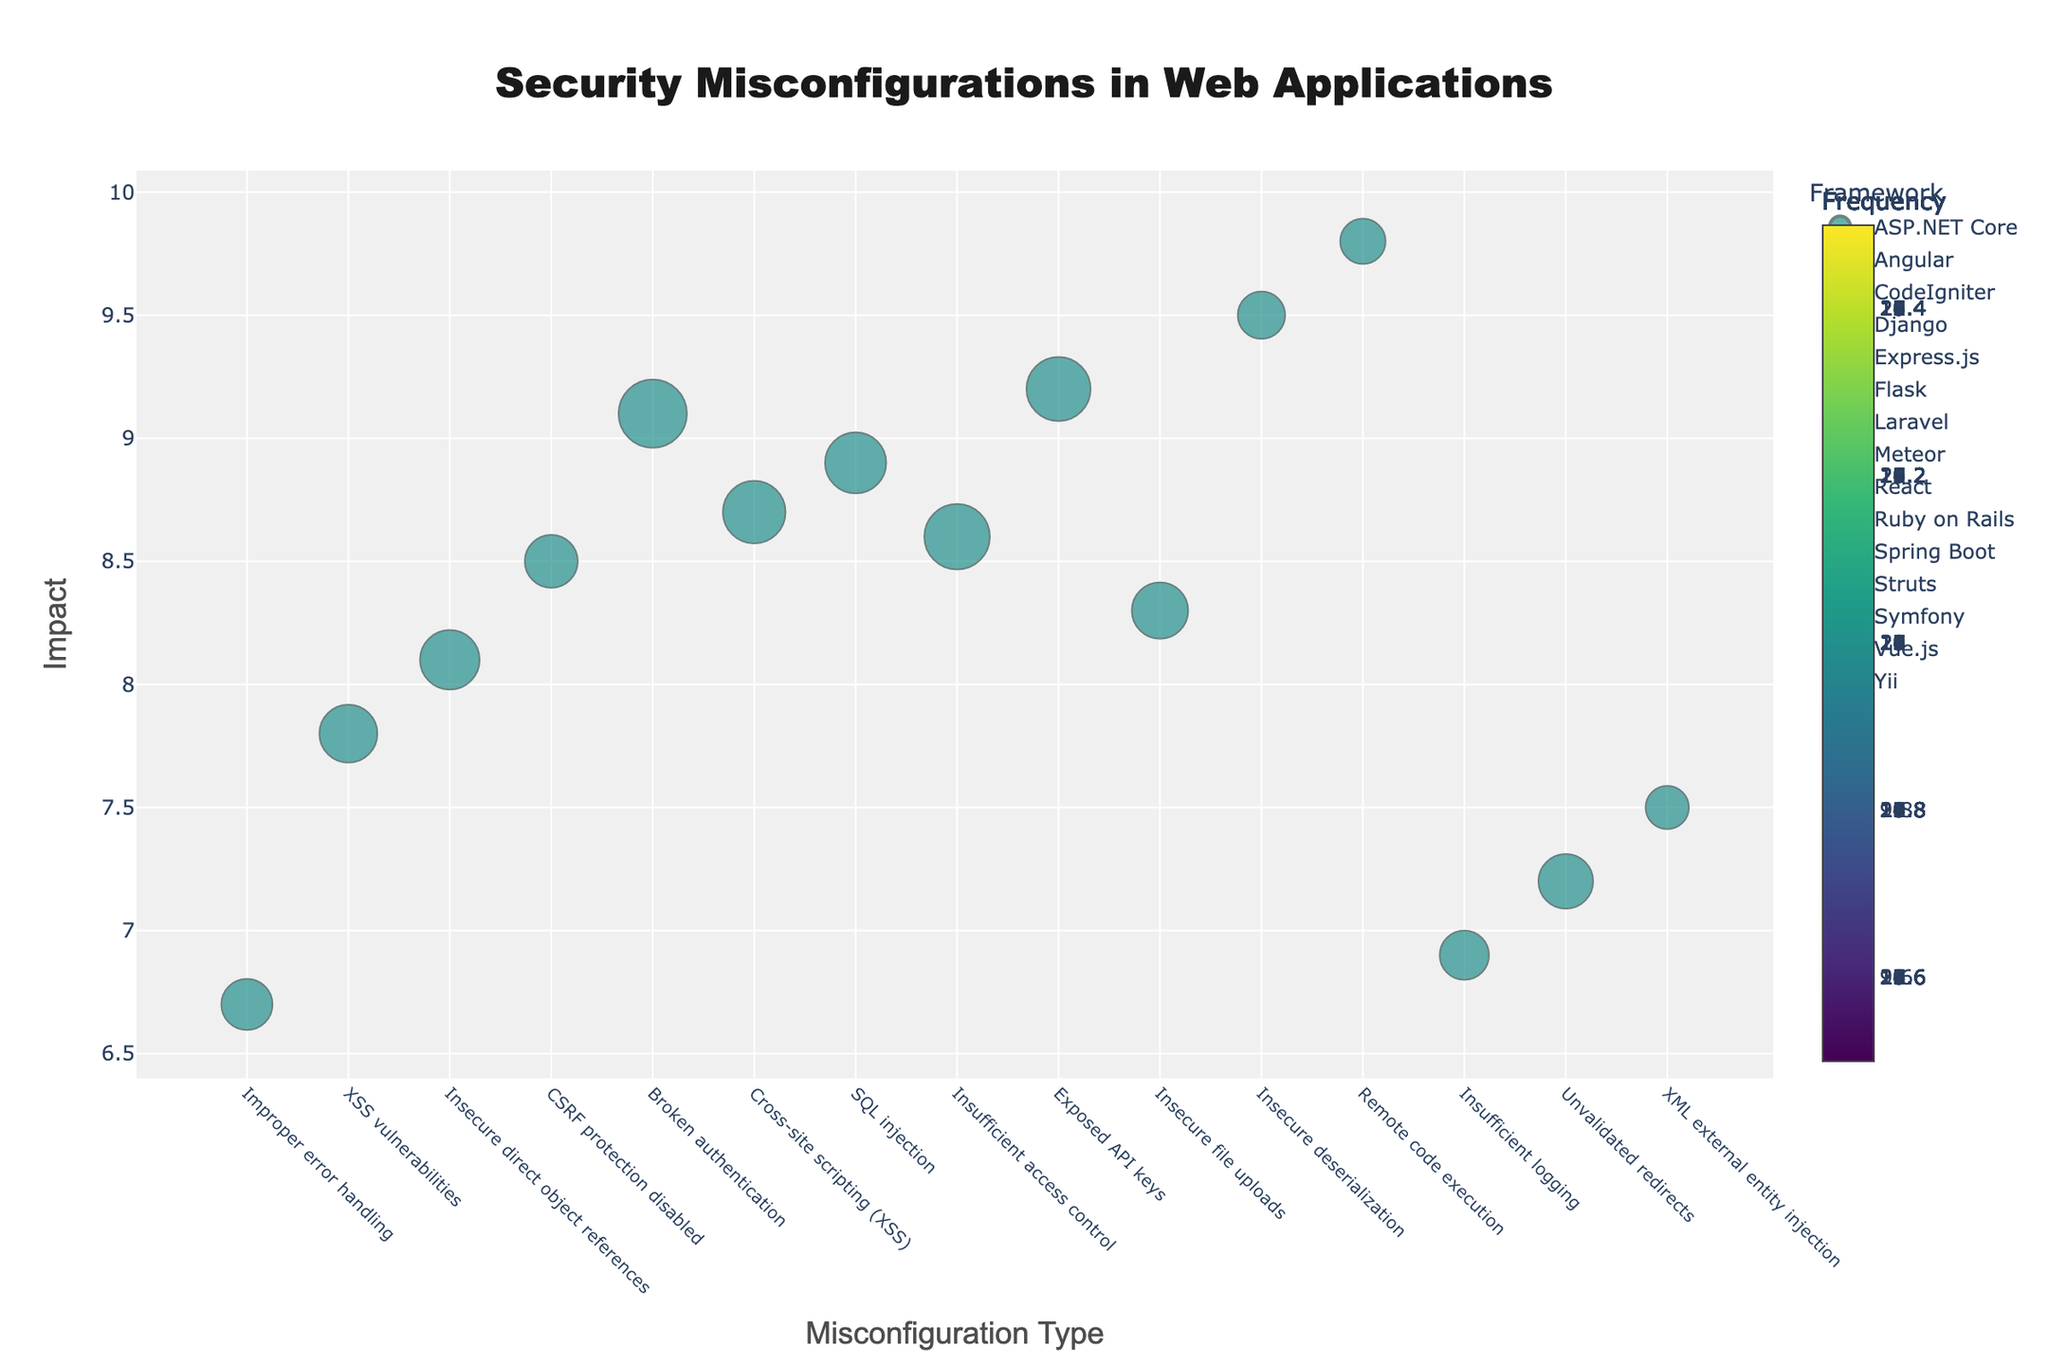What is the misconfiguration with the highest impact? By examining the y-axis, which denotes the impact, the misconfiguration with the highest position on this axis is identified.
Answer: Remote code execution in Struts What is the frequency of XSS vulnerabilities in Angular? Identify the data point related to "XSS vulnerabilities" in Angular, then read the size and color of the point, which corresponds to the frequency.
Answer: 18 Which framework has the most frequent misconfiguration, and what is it? Look for the largest marker on the plot. The size of the marker represents frequency. Find the framework associated with this marker.
Answer: Express.js with Broken authentication How many frameworks have an impact score above 9.0? Identify the data points that have an impact value above 9.0 on the y-axis and count the unique frameworks associated with these points.
Answer: 5 Which misconfiguration in Flask has an impact of 8.7? Find the data points associated with Flask and locate the one positioned at an impact of 8.7 on the y-axis.
Answer: Cross-site scripting (XSS) What is the average impact of misconfigurations in Django and Flask? Locate the respective impact values of misconfigurations in Django and Flask, sum these values, and divide by the number of respective data points.
Answer: (8.5 + 8.7) / 2 = 8.6 Which framework has the widest range of impact values? Determine the range of impact values (difference between the highest and lowest impact values) for each framework by examining the markers' vertical positions. Compare the ranges.
Answer: React with Exposed API keys (highest) and Insufficient logging (lowest) Is there a framework with multiple misconfigurations of the same impact score? Check for any markers within a single framework having the exact same y-axis (impact) value.
Answer: No What is the total frequency of misconfigurations with an impact score of exactly 8.5? Identify the markers on the plot that align with an impact value of 8.5 and sum their respective frequencies.
Answer: 15 (Only Django's CSRF protection disabled) Compare the impact and frequency of SQL injection in Laravel vs. Insecure deserialization in Spring Boot. Locate the specific misconfigurations in Laravel and Spring Boot, then compare their impact values (y-axis) and the sizes/colors of the markers (frequency).
Answer: SQL injection in Laravel: Impact=8.9, Frequency=20; Insecure deserialization in Spring Boot: Impact=9.5, Frequency=12 